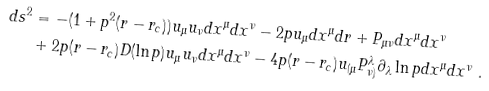Convert formula to latex. <formula><loc_0><loc_0><loc_500><loc_500>d s ^ { 2 } & = - ( 1 + p ^ { 2 } ( r - r _ { c } ) ) u _ { \mu } u _ { \nu } d x ^ { \mu } d x ^ { \nu } - 2 p u _ { \mu } d x ^ { \mu } d r + P _ { \mu \nu } d x ^ { \mu } d x ^ { \nu } \\ & + 2 p ( r - r _ { c } ) D ( \ln p ) u _ { \mu } u _ { \nu } d x ^ { \mu } d x ^ { \nu } - 4 p ( r - r _ { c } ) u _ { ( \mu } P ^ { \lambda } _ { \nu ) } \partial _ { \lambda } \ln p d x ^ { \mu } d x ^ { \nu } \ .</formula> 